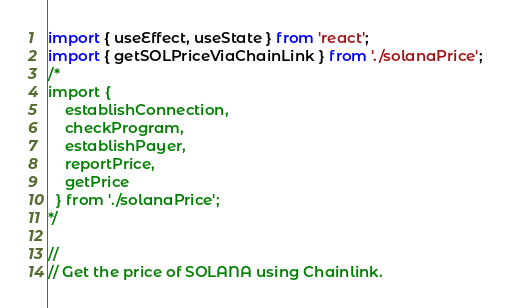Convert code to text. <code><loc_0><loc_0><loc_500><loc_500><_TypeScript_>import { useEffect, useState } from 'react';
import { getSOLPriceViaChainLink } from './solanaPrice';
/*    
import {
    establishConnection,
    checkProgram,
    establishPayer,
    reportPrice,
    getPrice
  } from './solanaPrice';
*/

//
// Get the price of SOLANA using Chainlink.  </code> 